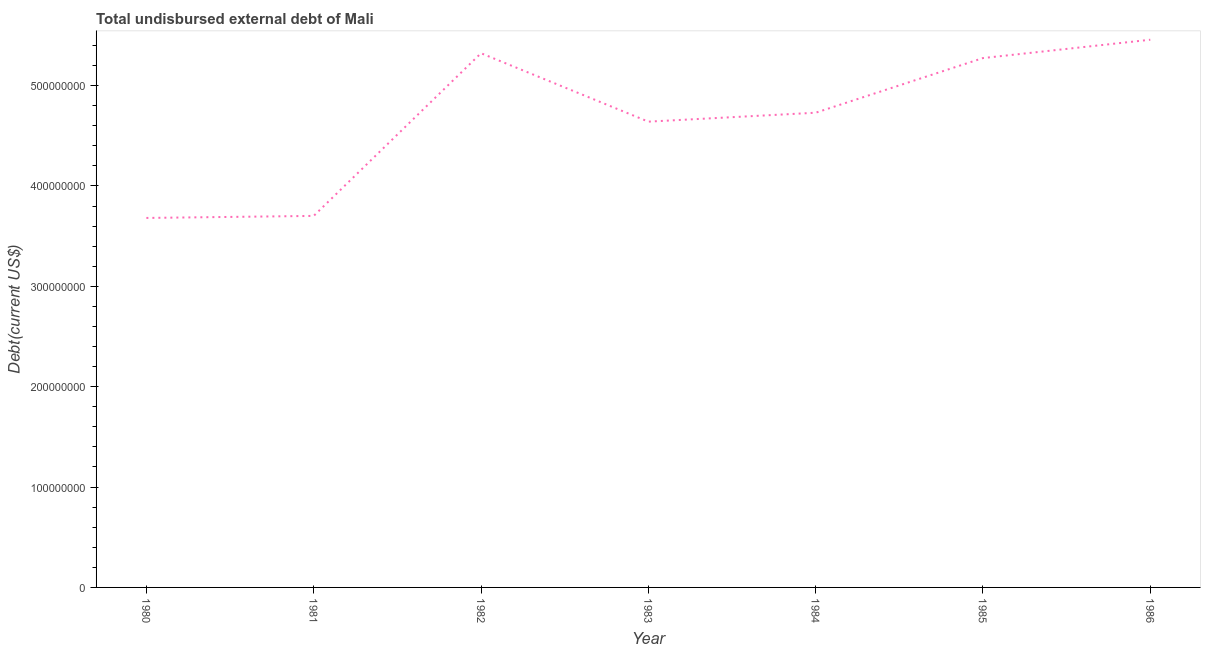What is the total debt in 1983?
Offer a terse response. 4.64e+08. Across all years, what is the maximum total debt?
Provide a succinct answer. 5.46e+08. Across all years, what is the minimum total debt?
Make the answer very short. 3.68e+08. In which year was the total debt minimum?
Keep it short and to the point. 1980. What is the sum of the total debt?
Make the answer very short. 3.28e+09. What is the difference between the total debt in 1982 and 1983?
Your answer should be very brief. 6.82e+07. What is the average total debt per year?
Your answer should be compact. 4.69e+08. What is the median total debt?
Keep it short and to the point. 4.73e+08. What is the ratio of the total debt in 1984 to that in 1985?
Your answer should be very brief. 0.9. What is the difference between the highest and the second highest total debt?
Your answer should be compact. 1.34e+07. What is the difference between the highest and the lowest total debt?
Your answer should be compact. 1.78e+08. In how many years, is the total debt greater than the average total debt taken over all years?
Provide a succinct answer. 4. Are the values on the major ticks of Y-axis written in scientific E-notation?
Ensure brevity in your answer.  No. What is the title of the graph?
Give a very brief answer. Total undisbursed external debt of Mali. What is the label or title of the X-axis?
Your answer should be very brief. Year. What is the label or title of the Y-axis?
Make the answer very short. Debt(current US$). What is the Debt(current US$) of 1980?
Provide a succinct answer. 3.68e+08. What is the Debt(current US$) of 1981?
Ensure brevity in your answer.  3.70e+08. What is the Debt(current US$) in 1982?
Make the answer very short. 5.32e+08. What is the Debt(current US$) in 1983?
Offer a terse response. 4.64e+08. What is the Debt(current US$) of 1984?
Your answer should be compact. 4.73e+08. What is the Debt(current US$) of 1985?
Provide a short and direct response. 5.27e+08. What is the Debt(current US$) in 1986?
Your answer should be very brief. 5.46e+08. What is the difference between the Debt(current US$) in 1980 and 1981?
Your answer should be very brief. -2.03e+06. What is the difference between the Debt(current US$) in 1980 and 1982?
Provide a short and direct response. -1.64e+08. What is the difference between the Debt(current US$) in 1980 and 1983?
Offer a terse response. -9.59e+07. What is the difference between the Debt(current US$) in 1980 and 1984?
Your answer should be very brief. -1.05e+08. What is the difference between the Debt(current US$) in 1980 and 1985?
Keep it short and to the point. -1.59e+08. What is the difference between the Debt(current US$) in 1980 and 1986?
Give a very brief answer. -1.78e+08. What is the difference between the Debt(current US$) in 1981 and 1982?
Provide a succinct answer. -1.62e+08. What is the difference between the Debt(current US$) in 1981 and 1983?
Keep it short and to the point. -9.39e+07. What is the difference between the Debt(current US$) in 1981 and 1984?
Offer a very short reply. -1.03e+08. What is the difference between the Debt(current US$) in 1981 and 1985?
Make the answer very short. -1.57e+08. What is the difference between the Debt(current US$) in 1981 and 1986?
Provide a short and direct response. -1.76e+08. What is the difference between the Debt(current US$) in 1982 and 1983?
Give a very brief answer. 6.82e+07. What is the difference between the Debt(current US$) in 1982 and 1984?
Your answer should be very brief. 5.93e+07. What is the difference between the Debt(current US$) in 1982 and 1985?
Your answer should be compact. 4.83e+06. What is the difference between the Debt(current US$) in 1982 and 1986?
Your response must be concise. -1.34e+07. What is the difference between the Debt(current US$) in 1983 and 1984?
Your response must be concise. -8.90e+06. What is the difference between the Debt(current US$) in 1983 and 1985?
Offer a very short reply. -6.34e+07. What is the difference between the Debt(current US$) in 1983 and 1986?
Keep it short and to the point. -8.16e+07. What is the difference between the Debt(current US$) in 1984 and 1985?
Keep it short and to the point. -5.45e+07. What is the difference between the Debt(current US$) in 1984 and 1986?
Give a very brief answer. -7.27e+07. What is the difference between the Debt(current US$) in 1985 and 1986?
Your response must be concise. -1.83e+07. What is the ratio of the Debt(current US$) in 1980 to that in 1982?
Your answer should be compact. 0.69. What is the ratio of the Debt(current US$) in 1980 to that in 1983?
Offer a very short reply. 0.79. What is the ratio of the Debt(current US$) in 1980 to that in 1984?
Keep it short and to the point. 0.78. What is the ratio of the Debt(current US$) in 1980 to that in 1985?
Your answer should be compact. 0.7. What is the ratio of the Debt(current US$) in 1980 to that in 1986?
Provide a succinct answer. 0.68. What is the ratio of the Debt(current US$) in 1981 to that in 1982?
Offer a very short reply. 0.69. What is the ratio of the Debt(current US$) in 1981 to that in 1983?
Offer a terse response. 0.8. What is the ratio of the Debt(current US$) in 1981 to that in 1984?
Keep it short and to the point. 0.78. What is the ratio of the Debt(current US$) in 1981 to that in 1985?
Your answer should be compact. 0.7. What is the ratio of the Debt(current US$) in 1981 to that in 1986?
Give a very brief answer. 0.68. What is the ratio of the Debt(current US$) in 1982 to that in 1983?
Provide a short and direct response. 1.15. What is the ratio of the Debt(current US$) in 1982 to that in 1985?
Your answer should be very brief. 1.01. What is the ratio of the Debt(current US$) in 1983 to that in 1985?
Provide a short and direct response. 0.88. What is the ratio of the Debt(current US$) in 1983 to that in 1986?
Give a very brief answer. 0.85. What is the ratio of the Debt(current US$) in 1984 to that in 1985?
Keep it short and to the point. 0.9. What is the ratio of the Debt(current US$) in 1984 to that in 1986?
Keep it short and to the point. 0.87. 